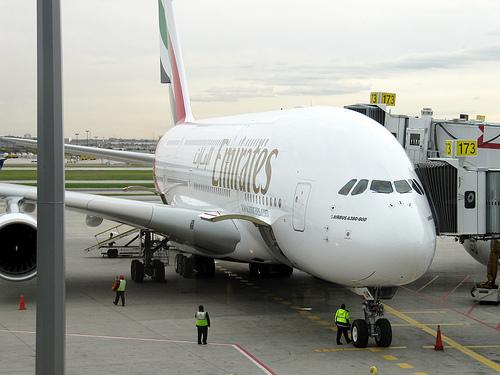Formulate a quick narrative explaining the main subject and related components in the image. A passenger airplane sits parked on the tarmac as airport workers, boarding tunnel, and traffic cones prepare it for takeoff, featuring a visible jet engine and cockpit windows. Provide a short report of the key events taking place in the image. A white Emirates airplane is parked on the tarmac, being boarded via a portable bridge, with personnel on the ground ensuring safety around the aircraft. Concisely depict the image, emphasizing the major elements. An Emirates airplane parked on the tarmac, near jet engine and landing gear, being serviced by airport workers in neon coats, with boarding bridge and pylons in view. Write a brief explanation of what can be observed in the picture. The image showcases an Emirates airliner parked at the tarmac being prepared for takeoff, with workers, traffic cones, and boarding tunnels in view. Summarize the image and name specific details you identify. Passenger airplane with its jet engine, cockpit windows, and name on the side, supported by landing gear, parked on the tarmac, as airport workers and traffic cones surround the area. Construct a short and detailed account of the image's subject and significant elements. A parked Emirates passenger plane on the tarmac is being attended by airport workers in safety vests and surrounded by orange traffic cones as a walkway connects for boarding. Give an outline of the scene displayed in the image. An airport scene featuring a white airplane on the tarmac, with an airport worker in neon coat, traffic cones, and a passenger boarding bridge. Create a concise description of the location of the main object in the image. A white airplane is parked on concrete tarmac with its boarding tunnel, workers, and traffic cones surrounding it. List the prominent components of the image in a brief explanation. The image features a parked passenger airplane, boarding ramp, workers in safety vests, traffic cones, and visible jet engine under the wing. Narrate the context and subject of the picture in a short description. An airplane is stationed on the tarmac, with workers attending to its tires and wings, while passengers enter via a loading bridge and safety pylons mark boundaries. 